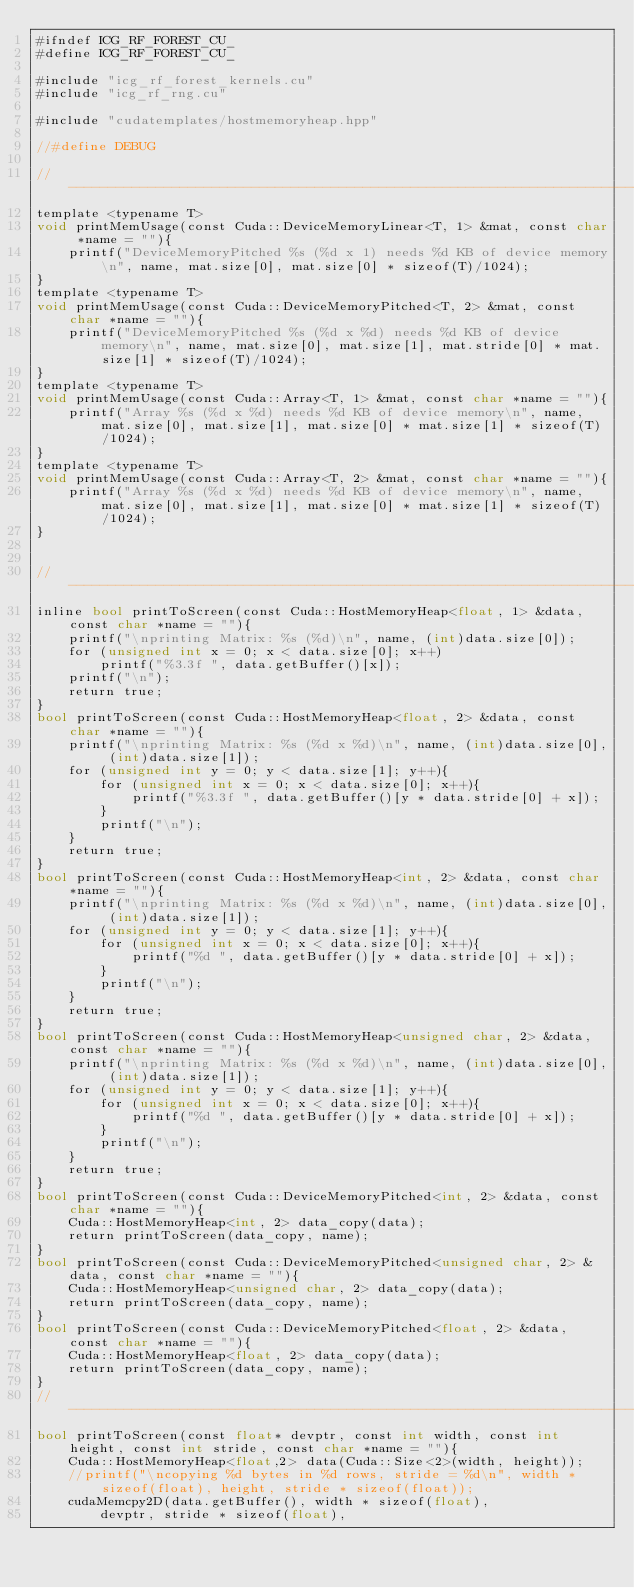<code> <loc_0><loc_0><loc_500><loc_500><_Cuda_>#ifndef ICG_RF_FOREST_CU_
#define ICG_RF_FOREST_CU_

#include "icg_rf_forest_kernels.cu"
#include "icg_rf_rng.cu"

#include "cudatemplates/hostmemoryheap.hpp" 

//#define DEBUG 

//-----------------------------------------------------------------------------
template <typename T>
void printMemUsage(const Cuda::DeviceMemoryLinear<T, 1> &mat, const char *name = ""){
    printf("DeviceMemoryPitched %s (%d x 1) needs %d KB of device memory\n", name, mat.size[0], mat.size[0] * sizeof(T)/1024);
}
template <typename T>
void printMemUsage(const Cuda::DeviceMemoryPitched<T, 2> &mat, const char *name = ""){
    printf("DeviceMemoryPitched %s (%d x %d) needs %d KB of device memory\n", name, mat.size[0], mat.size[1], mat.stride[0] * mat.size[1] * sizeof(T)/1024);
}
template <typename T>
void printMemUsage(const Cuda::Array<T, 1> &mat, const char *name = ""){
    printf("Array %s (%d x %d) needs %d KB of device memory\n", name, mat.size[0], mat.size[1], mat.size[0] * mat.size[1] * sizeof(T)/1024);
}
template <typename T>
void printMemUsage(const Cuda::Array<T, 2> &mat, const char *name = ""){
    printf("Array %s (%d x %d) needs %d KB of device memory\n", name, mat.size[0], mat.size[1], mat.size[0] * mat.size[1] * sizeof(T)/1024);
}


//-----------------------------------------------------------------------------
inline bool printToScreen(const Cuda::HostMemoryHeap<float, 1> &data, const char *name = ""){
    printf("\nprinting Matrix: %s (%d)\n", name, (int)data.size[0]);
    for (unsigned int x = 0; x < data.size[0]; x++)
        printf("%3.3f ", data.getBuffer()[x]);
    printf("\n");
    return true;
}
bool printToScreen(const Cuda::HostMemoryHeap<float, 2> &data, const char *name = ""){
    printf("\nprinting Matrix: %s (%d x %d)\n", name, (int)data.size[0], (int)data.size[1]);
    for (unsigned int y = 0; y < data.size[1]; y++){
        for (unsigned int x = 0; x < data.size[0]; x++){
            printf("%3.3f ", data.getBuffer()[y * data.stride[0] + x]);
        }
        printf("\n");
    }
    return true;
} 
bool printToScreen(const Cuda::HostMemoryHeap<int, 2> &data, const char *name = ""){
    printf("\nprinting Matrix: %s (%d x %d)\n", name, (int)data.size[0], (int)data.size[1]);
    for (unsigned int y = 0; y < data.size[1]; y++){
        for (unsigned int x = 0; x < data.size[0]; x++){
            printf("%d ", data.getBuffer()[y * data.stride[0] + x]);
        }
        printf("\n");
    }
    return true;
} 
bool printToScreen(const Cuda::HostMemoryHeap<unsigned char, 2> &data, const char *name = ""){
    printf("\nprinting Matrix: %s (%d x %d)\n", name, (int)data.size[0], (int)data.size[1]);
    for (unsigned int y = 0; y < data.size[1]; y++){
        for (unsigned int x = 0; x < data.size[0]; x++){
            printf("%d ", data.getBuffer()[y * data.stride[0] + x]);
        }
        printf("\n");
    }
    return true;
} 
bool printToScreen(const Cuda::DeviceMemoryPitched<int, 2> &data, const char *name = ""){
    Cuda::HostMemoryHeap<int, 2> data_copy(data);
    return printToScreen(data_copy, name);
}
bool printToScreen(const Cuda::DeviceMemoryPitched<unsigned char, 2> &data, const char *name = ""){
    Cuda::HostMemoryHeap<unsigned char, 2> data_copy(data);
    return printToScreen(data_copy, name);
}
bool printToScreen(const Cuda::DeviceMemoryPitched<float, 2> &data, const char *name = ""){
    Cuda::HostMemoryHeap<float, 2> data_copy(data);
    return printToScreen(data_copy, name);
}
//-----------------------------------------------------------------------------
bool printToScreen(const float* devptr, const int width, const int height, const int stride, const char *name = ""){
    Cuda::HostMemoryHeap<float,2> data(Cuda::Size<2>(width, height));
    //printf("\ncopying %d bytes in %d rows, stride = %d\n", width * sizeof(float), height, stride * sizeof(float));
    cudaMemcpy2D(data.getBuffer(), width * sizeof(float),
        devptr, stride * sizeof(float),</code> 